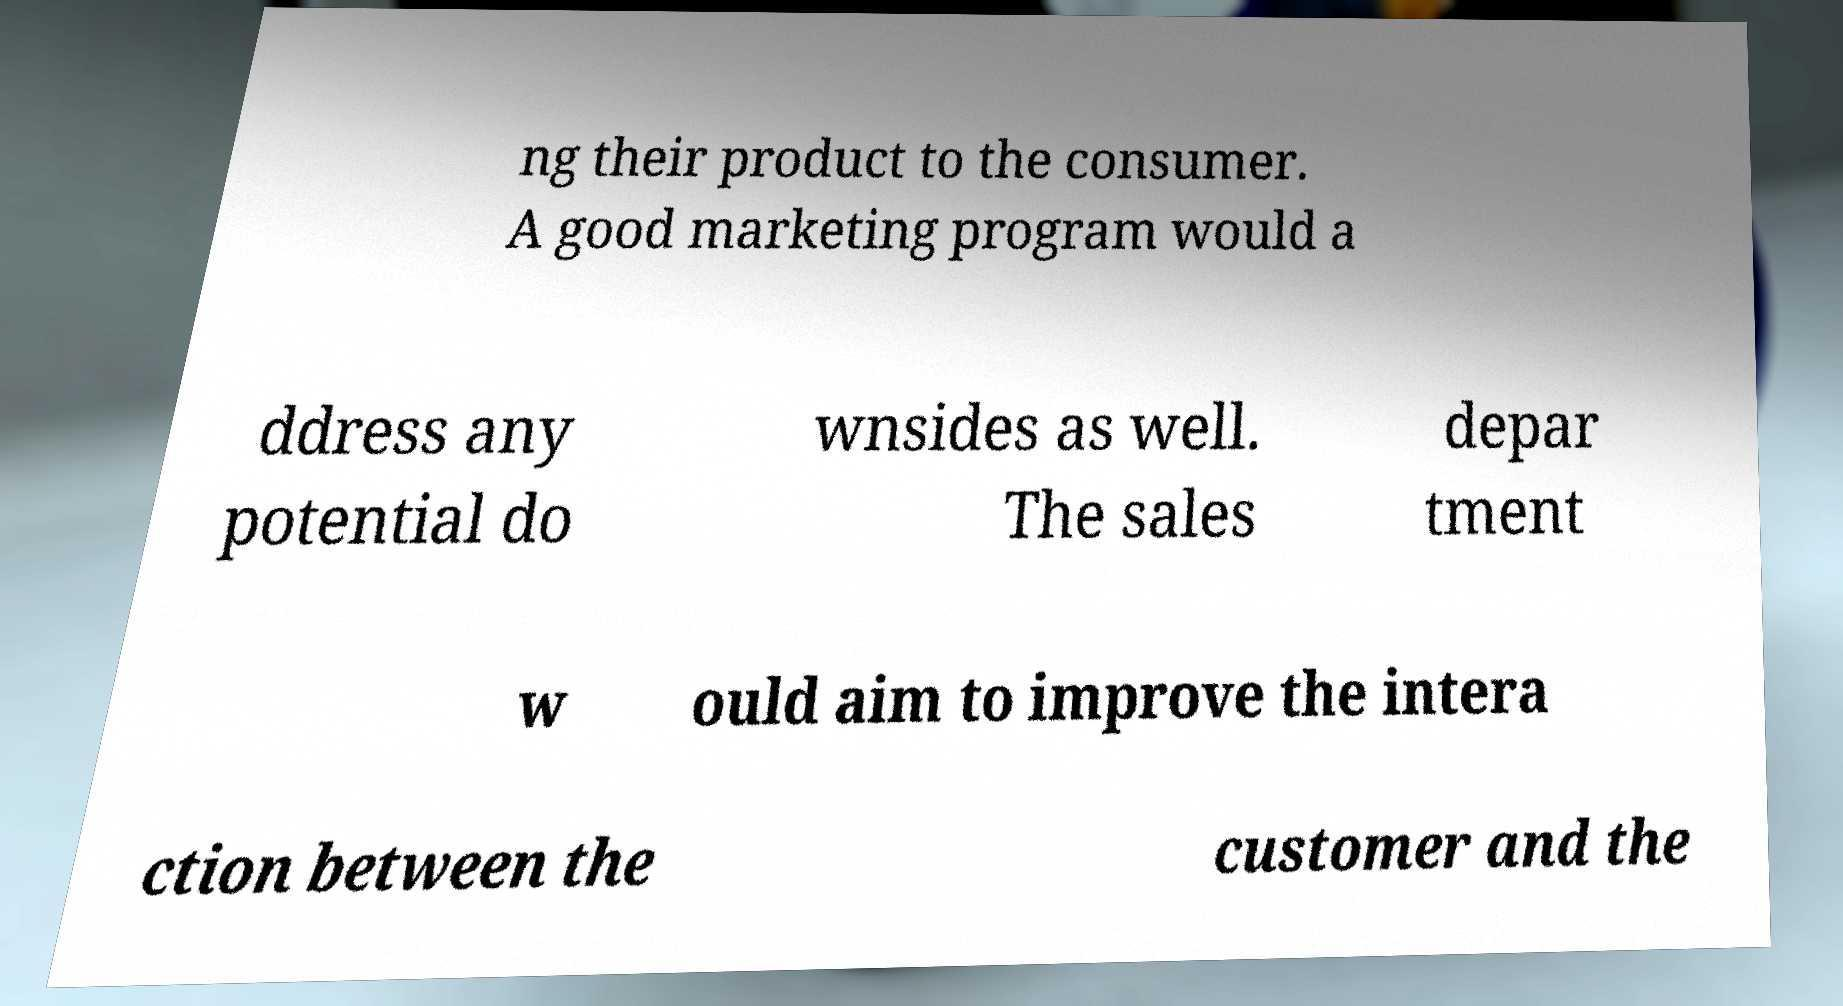For documentation purposes, I need the text within this image transcribed. Could you provide that? ng their product to the consumer. A good marketing program would a ddress any potential do wnsides as well. The sales depar tment w ould aim to improve the intera ction between the customer and the 